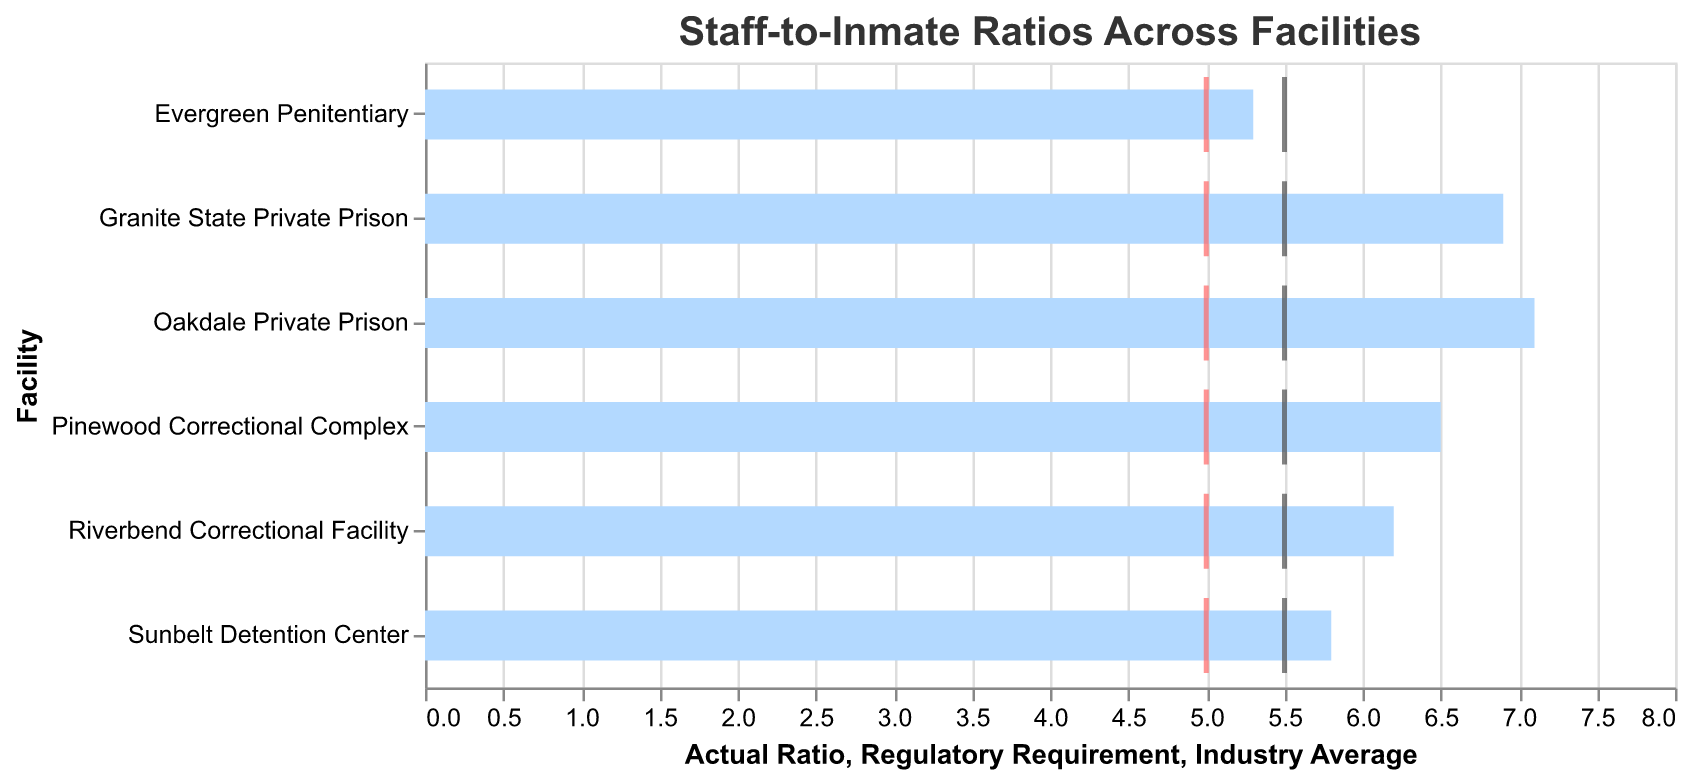What is the actual staff-to-inmate ratio for Oakdale Private Prison? The staff-to-inmate ratio for Oakdale Private Prison can be directly seen in the bar representation on the figure, which indicates the actual ratio.
Answer: 1:7.1 How many facilities have a staff-to-inmate ratio greater than the regulatory requirement? By counting the bars that extend right past the red ticks (regulatory requirements), we find that there are five facilities exceeding the regulatory requirement.
Answer: Five Which facility has the lowest staff-to-inmate ratio? The shortest bar on the chart represents the facility with the lowest staff-to-inmate ratio.
Answer: Evergreen Penitentiary What is the difference between the actual ratio and the regulatory requirement for Pinewood Correctional Complex? To find the difference, subtract the regulatory requirement (1:5) from the actual ratio (1:6.5).
Answer: 1.5 Which facility is closest to meeting the industry average? The facility whose bar is closest to the gray tick (industry average) is Evergreen Penitentiary.
Answer: Evergreen Penitentiary How does the Sunbelt Detention Center compare to the regulatory requirement? Observe that the bar for Sunbelt Detention Center extends right past the red tick mark. This indicates that their actual ratio is slightly higher than the regulatory requirement.
Answer: Higher Which facilities have an actual ratio greater than both the regulatory requirement and the industry average? Count the bars that extend right past both the red and gray ticks. Facilities with bars exceeding both thresholds are Riverbend Correctional Facility, Oakdale Private Prison, Pinewood Correctional Complex, and Granite State Private Prison.
Answer: Four facilities (Riverbend, Oakdale, Pinewood, Granite State) What is the average staff-to-inmate ratio of all the facilities? To calculate the average, sum all actual ratios (6.2 + 7.1 + 5.8 + 6.5 + 5.3 + 6.9) and then divide by the number of facilities (6). The sum is 37.8, so the average is 37.8/6.
Answer: 6.3 